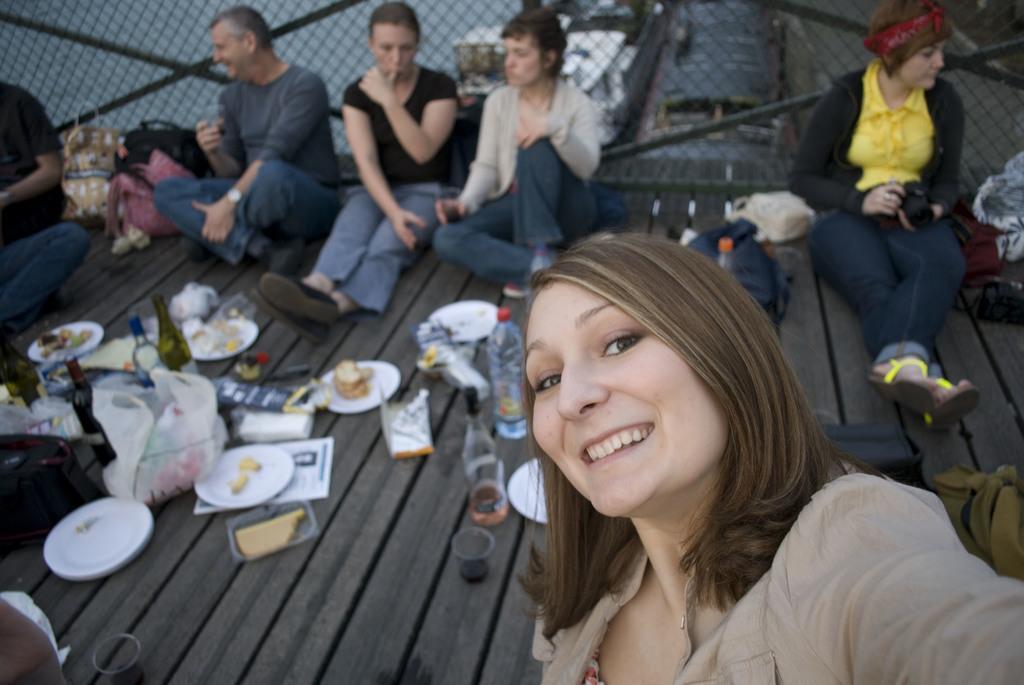Could you give a brief overview of what you see in this image? In this image we can see some people sitting on the floor which contains bottles, plates, snacks, glasses, tissue papers and some food. On the backside we can see a fence. 